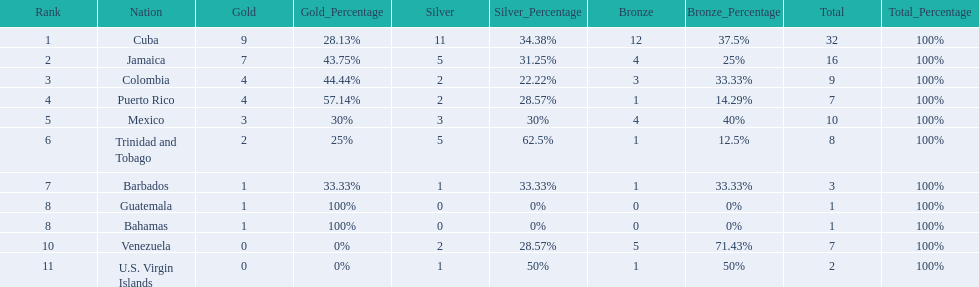What is the difference in medals between cuba and mexico? 22. 